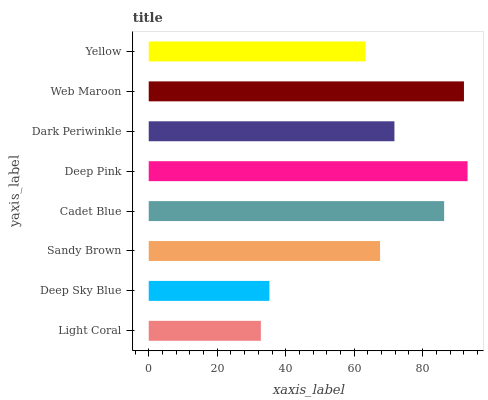Is Light Coral the minimum?
Answer yes or no. Yes. Is Deep Pink the maximum?
Answer yes or no. Yes. Is Deep Sky Blue the minimum?
Answer yes or no. No. Is Deep Sky Blue the maximum?
Answer yes or no. No. Is Deep Sky Blue greater than Light Coral?
Answer yes or no. Yes. Is Light Coral less than Deep Sky Blue?
Answer yes or no. Yes. Is Light Coral greater than Deep Sky Blue?
Answer yes or no. No. Is Deep Sky Blue less than Light Coral?
Answer yes or no. No. Is Dark Periwinkle the high median?
Answer yes or no. Yes. Is Sandy Brown the low median?
Answer yes or no. Yes. Is Light Coral the high median?
Answer yes or no. No. Is Yellow the low median?
Answer yes or no. No. 